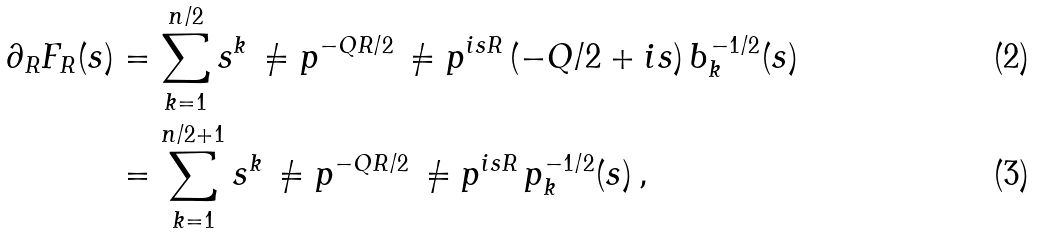Convert formula to latex. <formula><loc_0><loc_0><loc_500><loc_500>\partial _ { R } F _ { R } ( s ) & = \sum _ { k = 1 } ^ { n / 2 } s ^ { k } \, \ne p ^ { - Q R / 2 } \, \ne p ^ { i s R } \, ( - Q / 2 + i s ) \, b _ { k } ^ { - 1 / 2 } ( s ) \\ & = \sum _ { k = 1 } ^ { n / 2 + 1 } s ^ { k } \, \ne p ^ { - Q R / 2 } \, \ne p ^ { i s R } \, p _ { k } ^ { - 1 / 2 } ( s ) \, ,</formula> 